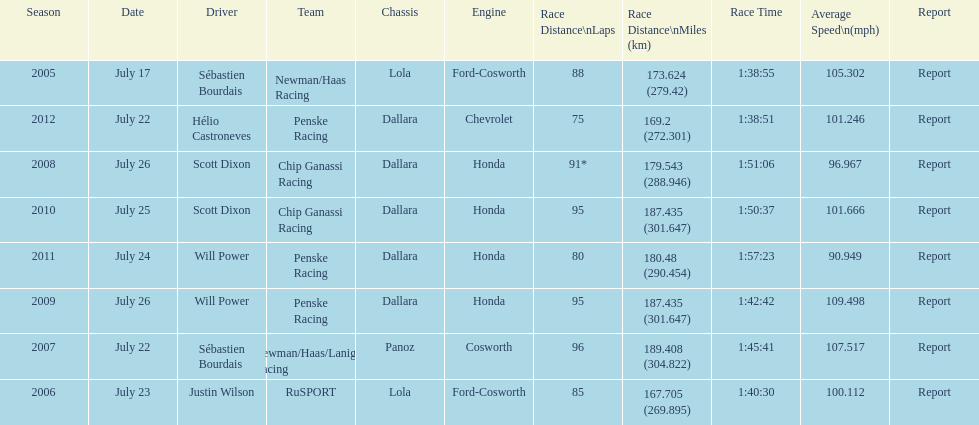How many total honda engines were there? 4. Can you parse all the data within this table? {'header': ['Season', 'Date', 'Driver', 'Team', 'Chassis', 'Engine', 'Race Distance\\nLaps', 'Race Distance\\nMiles (km)', 'Race Time', 'Average Speed\\n(mph)', 'Report'], 'rows': [['2005', 'July 17', 'Sébastien Bourdais', 'Newman/Haas Racing', 'Lola', 'Ford-Cosworth', '88', '173.624 (279.42)', '1:38:55', '105.302', 'Report'], ['2012', 'July 22', 'Hélio Castroneves', 'Penske Racing', 'Dallara', 'Chevrolet', '75', '169.2 (272.301)', '1:38:51', '101.246', 'Report'], ['2008', 'July 26', 'Scott Dixon', 'Chip Ganassi Racing', 'Dallara', 'Honda', '91*', '179.543 (288.946)', '1:51:06', '96.967', 'Report'], ['2010', 'July 25', 'Scott Dixon', 'Chip Ganassi Racing', 'Dallara', 'Honda', '95', '187.435 (301.647)', '1:50:37', '101.666', 'Report'], ['2011', 'July 24', 'Will Power', 'Penske Racing', 'Dallara', 'Honda', '80', '180.48 (290.454)', '1:57:23', '90.949', 'Report'], ['2009', 'July 26', 'Will Power', 'Penske Racing', 'Dallara', 'Honda', '95', '187.435 (301.647)', '1:42:42', '109.498', 'Report'], ['2007', 'July 22', 'Sébastien Bourdais', 'Newman/Haas/Lanigan Racing', 'Panoz', 'Cosworth', '96', '189.408 (304.822)', '1:45:41', '107.517', 'Report'], ['2006', 'July 23', 'Justin Wilson', 'RuSPORT', 'Lola', 'Ford-Cosworth', '85', '167.705 (269.895)', '1:40:30', '100.112', 'Report']]} 